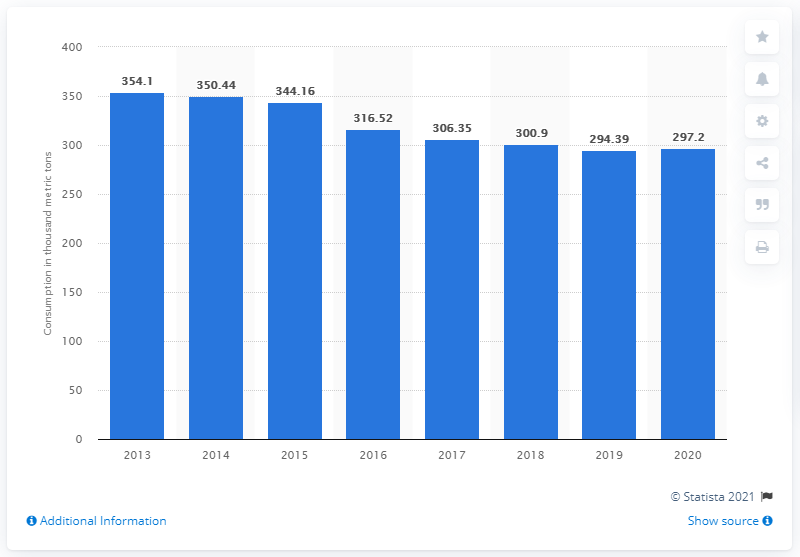Indicate a few pertinent items in this graphic. In the year 2013, pork was first consumed in India. 